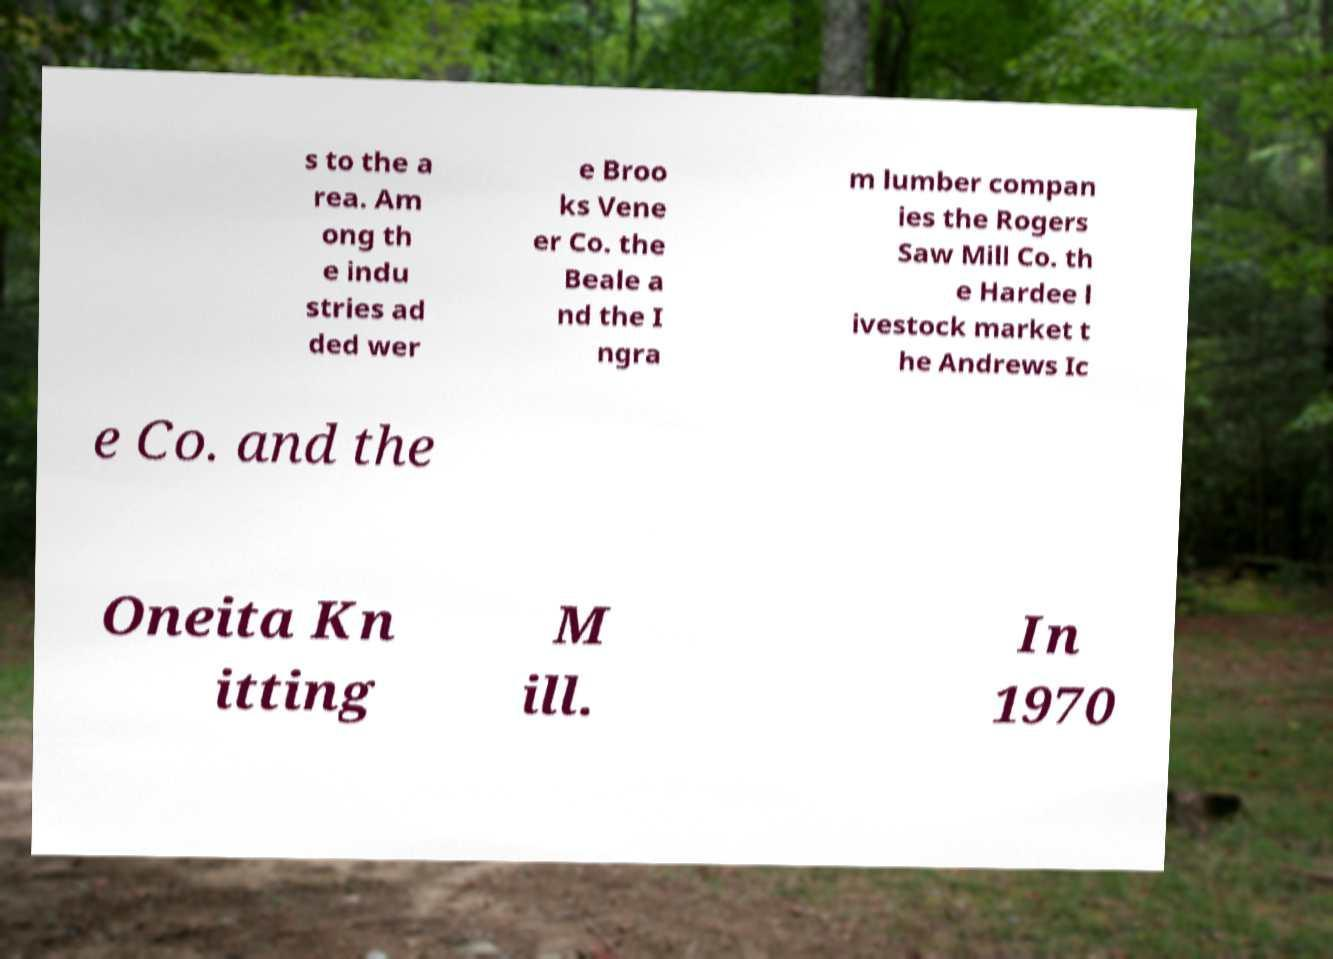I need the written content from this picture converted into text. Can you do that? s to the a rea. Am ong th e indu stries ad ded wer e Broo ks Vene er Co. the Beale a nd the I ngra m lumber compan ies the Rogers Saw Mill Co. th e Hardee l ivestock market t he Andrews Ic e Co. and the Oneita Kn itting M ill. In 1970 